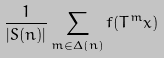<formula> <loc_0><loc_0><loc_500><loc_500>\frac { 1 } { | S ( n ) | } \sum _ { m \in \Delta ( n ) } f ( T ^ { m } x )</formula> 